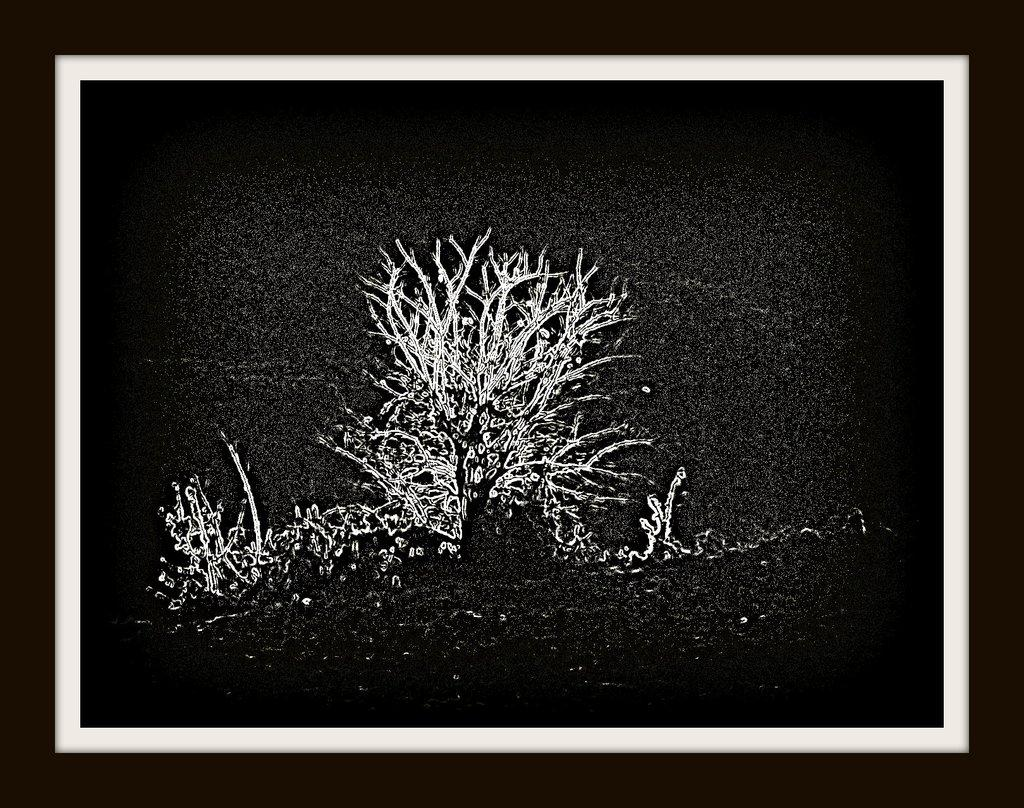What object is present in the image that typically holds a photograph? There is a photo frame in the image. What is the color scheme of the image inside the frame? The image inside the frame is black and white. What type of sponge can be seen in the image? There is no sponge present in the image. How does the photo frame look at the person viewing it from a different angle? The photo frame's appearance does not change based on the viewer's angle, as it is a static object in the image. 